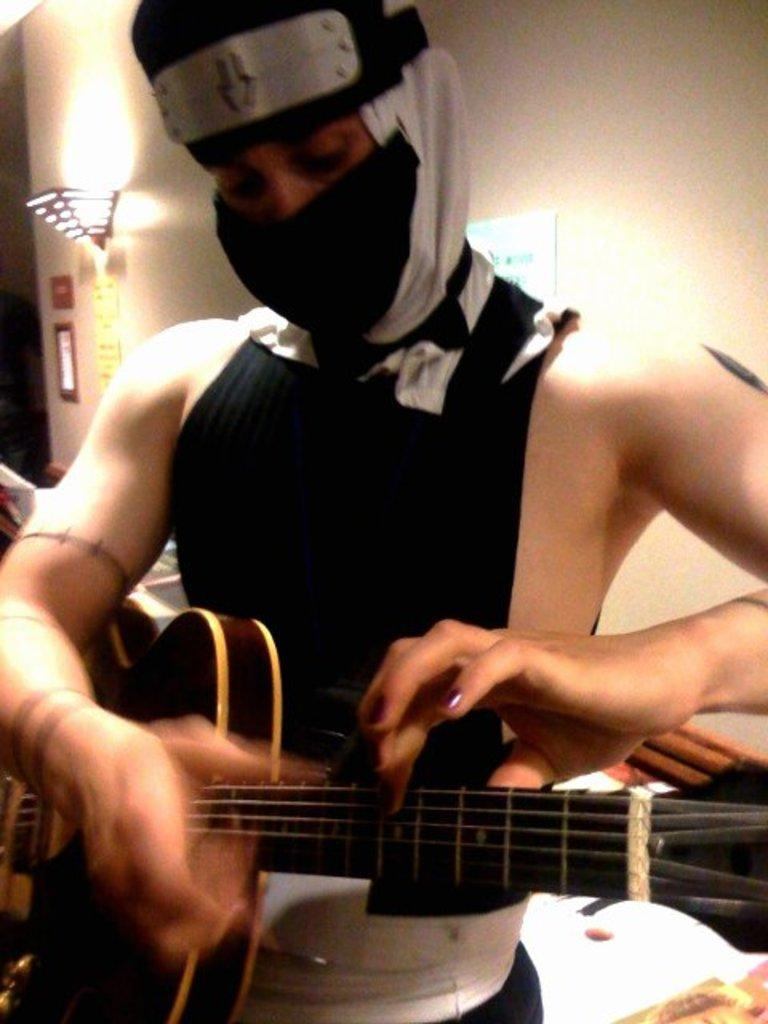What is the person in the image holding? The person is holding a guitar. Can you describe the person's appearance in the image? The person's face is covered with cloth. What can be seen in the background of the image? There is a wall, a picture frame, and a wall lamp in the background of the image. How many horses are visible in the image? There are no horses present in the image. What type of alley can be seen in the background of the image? There is no alley visible in the image; it features a wall, a picture frame, and a wall lamp in the background. 